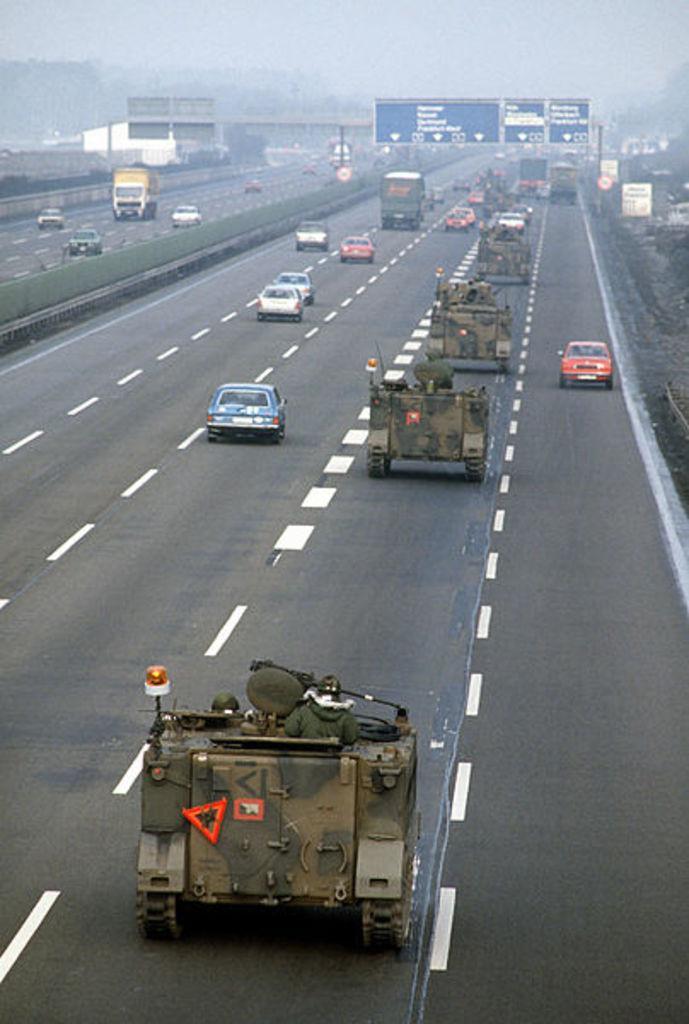How would you summarize this image in a sentence or two? In this image I see the road on which there are white lines and I see there are many vehicles and I see the tankers and I see the boards over here on which there are words written and I see the fog in the background. 